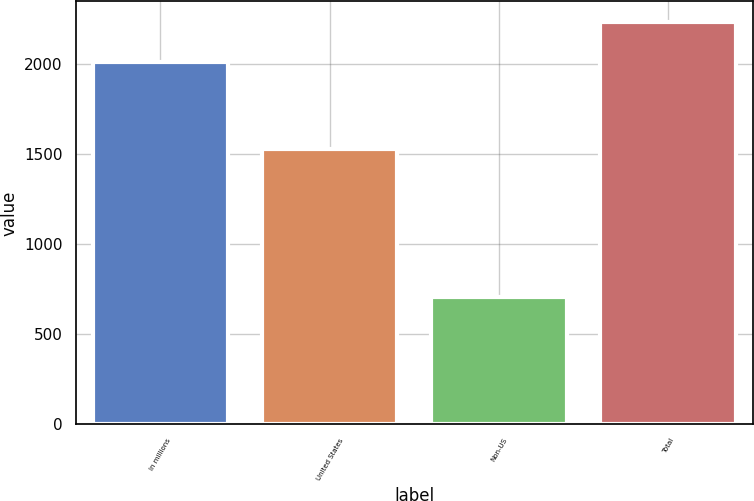Convert chart. <chart><loc_0><loc_0><loc_500><loc_500><bar_chart><fcel>In millions<fcel>United States<fcel>Non-US<fcel>Total<nl><fcel>2016<fcel>1531.2<fcel>706.8<fcel>2238<nl></chart> 